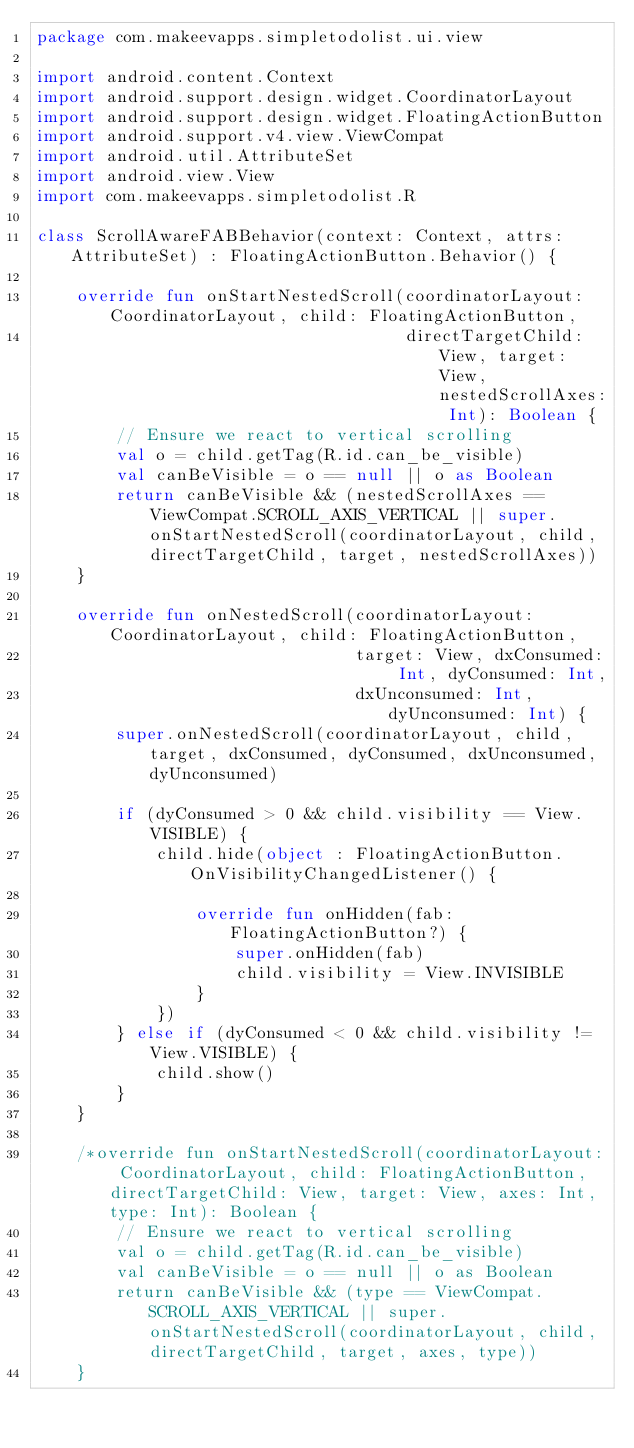Convert code to text. <code><loc_0><loc_0><loc_500><loc_500><_Kotlin_>package com.makeevapps.simpletodolist.ui.view

import android.content.Context
import android.support.design.widget.CoordinatorLayout
import android.support.design.widget.FloatingActionButton
import android.support.v4.view.ViewCompat
import android.util.AttributeSet
import android.view.View
import com.makeevapps.simpletodolist.R

class ScrollAwareFABBehavior(context: Context, attrs: AttributeSet) : FloatingActionButton.Behavior() {

    override fun onStartNestedScroll(coordinatorLayout: CoordinatorLayout, child: FloatingActionButton,
                                     directTargetChild: View, target: View, nestedScrollAxes: Int): Boolean {
        // Ensure we react to vertical scrolling
        val o = child.getTag(R.id.can_be_visible)
        val canBeVisible = o == null || o as Boolean
        return canBeVisible && (nestedScrollAxes == ViewCompat.SCROLL_AXIS_VERTICAL || super.onStartNestedScroll(coordinatorLayout, child, directTargetChild, target, nestedScrollAxes))
    }

    override fun onNestedScroll(coordinatorLayout: CoordinatorLayout, child: FloatingActionButton,
                                target: View, dxConsumed: Int, dyConsumed: Int,
                                dxUnconsumed: Int, dyUnconsumed: Int) {
        super.onNestedScroll(coordinatorLayout, child, target, dxConsumed, dyConsumed, dxUnconsumed, dyUnconsumed)

        if (dyConsumed > 0 && child.visibility == View.VISIBLE) {
            child.hide(object : FloatingActionButton.OnVisibilityChangedListener() {

                override fun onHidden(fab: FloatingActionButton?) {
                    super.onHidden(fab)
                    child.visibility = View.INVISIBLE
                }
            })
        } else if (dyConsumed < 0 && child.visibility != View.VISIBLE) {
            child.show()
        }
    }

    /*override fun onStartNestedScroll(coordinatorLayout: CoordinatorLayout, child: FloatingActionButton, directTargetChild: View, target: View, axes: Int, type: Int): Boolean {
        // Ensure we react to vertical scrolling
        val o = child.getTag(R.id.can_be_visible)
        val canBeVisible = o == null || o as Boolean
        return canBeVisible && (type == ViewCompat.SCROLL_AXIS_VERTICAL || super.onStartNestedScroll(coordinatorLayout, child, directTargetChild, target, axes, type))
    }
</code> 